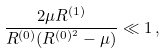<formula> <loc_0><loc_0><loc_500><loc_500>\frac { 2 \mu R ^ { ( 1 ) } } { R ^ { ( 0 ) } ( R ^ { ( 0 ) ^ { 2 } } - \mu ) } \ll 1 \, ,</formula> 